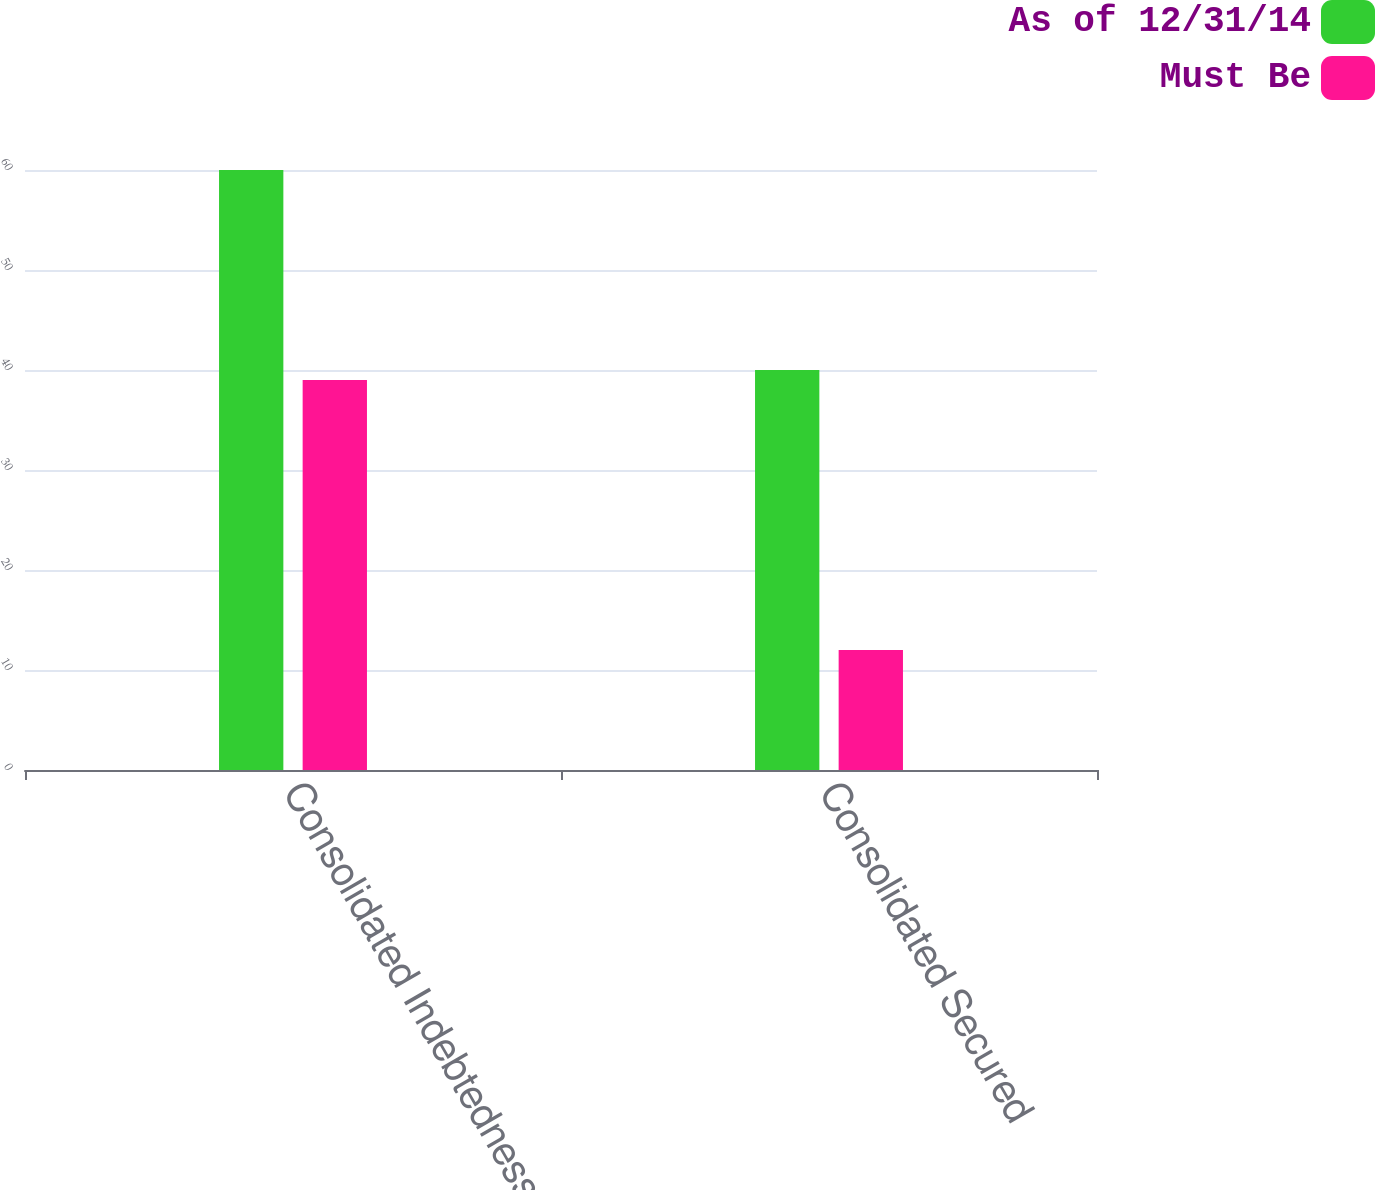Convert chart. <chart><loc_0><loc_0><loc_500><loc_500><stacked_bar_chart><ecel><fcel>Consolidated Indebtedness to<fcel>Consolidated Secured<nl><fcel>As of 12/31/14<fcel>60<fcel>40<nl><fcel>Must Be<fcel>39<fcel>12<nl></chart> 